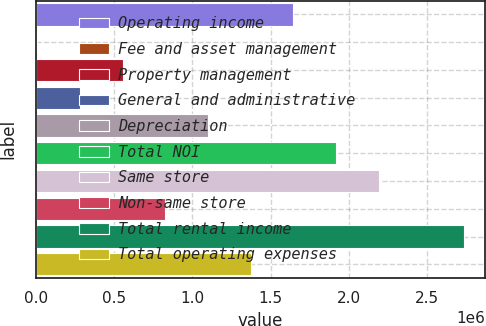<chart> <loc_0><loc_0><loc_500><loc_500><bar_chart><fcel>Operating income<fcel>Fee and asset management<fcel>Property management<fcel>General and administrative<fcel>Depreciation<fcel>Total NOI<fcel>Same store<fcel>Non-same store<fcel>Total rental income<fcel>Total operating expenses<nl><fcel>1.6453e+06<fcel>8387<fcel>554025<fcel>281206<fcel>1.09966e+06<fcel>1.91812e+06<fcel>2.19094e+06<fcel>826844<fcel>2.73658e+06<fcel>1.37248e+06<nl></chart> 